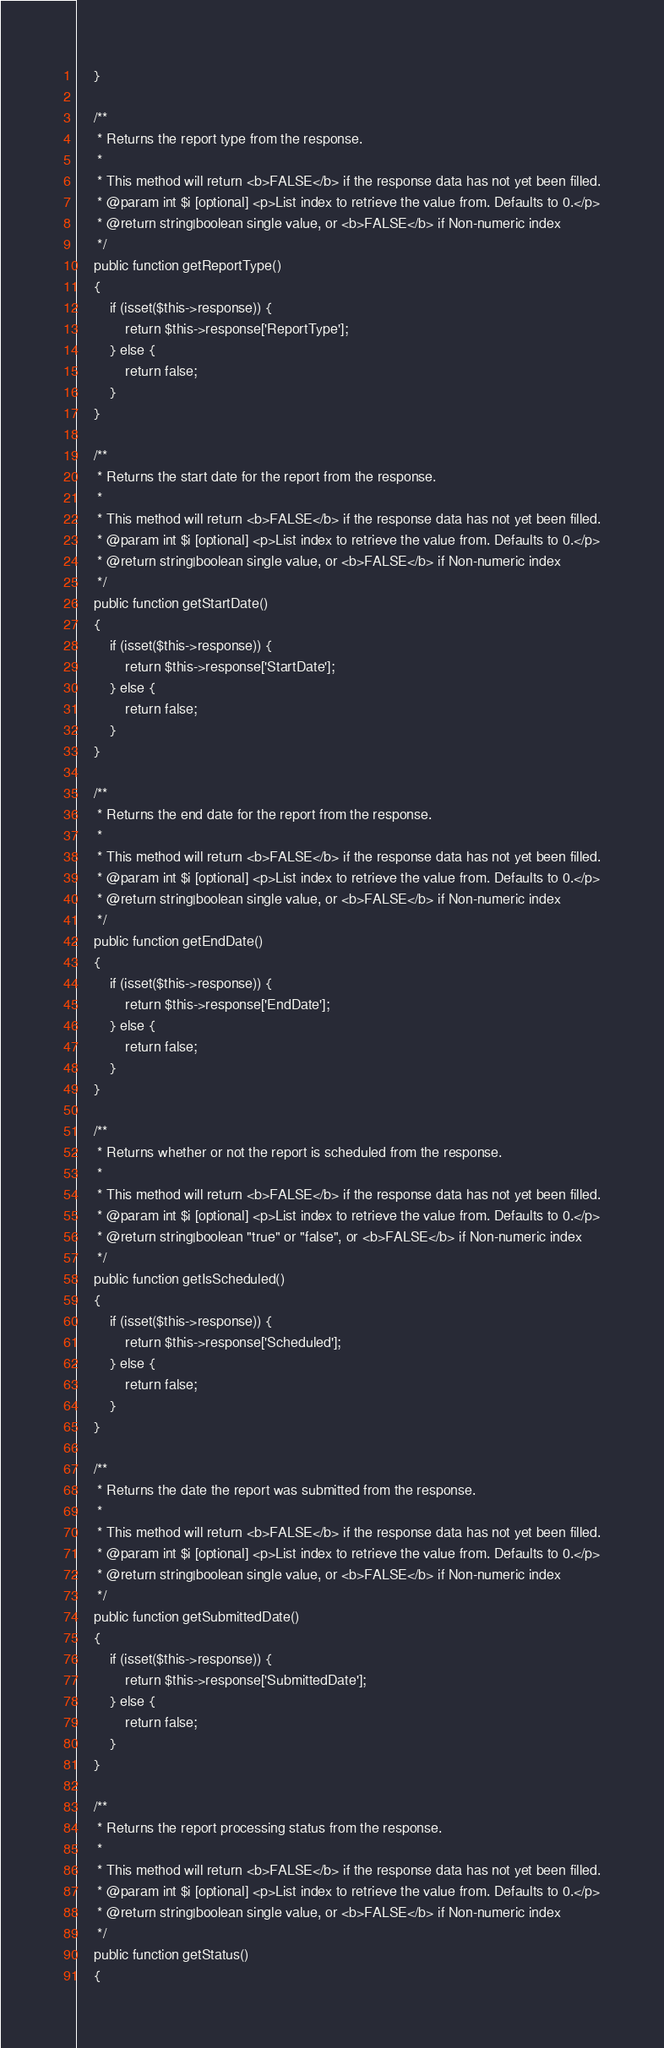Convert code to text. <code><loc_0><loc_0><loc_500><loc_500><_PHP_>    }

    /**
     * Returns the report type from the response.
     *
     * This method will return <b>FALSE</b> if the response data has not yet been filled.
     * @param int $i [optional] <p>List index to retrieve the value from. Defaults to 0.</p>
     * @return string|boolean single value, or <b>FALSE</b> if Non-numeric index
     */
    public function getReportType()
    {
        if (isset($this->response)) {
            return $this->response['ReportType'];
        } else {
            return false;
        }
    }

    /**
     * Returns the start date for the report from the response.
     *
     * This method will return <b>FALSE</b> if the response data has not yet been filled.
     * @param int $i [optional] <p>List index to retrieve the value from. Defaults to 0.</p>
     * @return string|boolean single value, or <b>FALSE</b> if Non-numeric index
     */
    public function getStartDate()
    {
        if (isset($this->response)) {
            return $this->response['StartDate'];
        } else {
            return false;
        }
    }

    /**
     * Returns the end date for the report from the response.
     *
     * This method will return <b>FALSE</b> if the response data has not yet been filled.
     * @param int $i [optional] <p>List index to retrieve the value from. Defaults to 0.</p>
     * @return string|boolean single value, or <b>FALSE</b> if Non-numeric index
     */
    public function getEndDate()
    {
        if (isset($this->response)) {
            return $this->response['EndDate'];
        } else {
            return false;
        }
    }

    /**
     * Returns whether or not the report is scheduled from the response.
     *
     * This method will return <b>FALSE</b> if the response data has not yet been filled.
     * @param int $i [optional] <p>List index to retrieve the value from. Defaults to 0.</p>
     * @return string|boolean "true" or "false", or <b>FALSE</b> if Non-numeric index
     */
    public function getIsScheduled()
    {
        if (isset($this->response)) {
            return $this->response['Scheduled'];
        } else {
            return false;
        }
    }

    /**
     * Returns the date the report was submitted from the response.
     *
     * This method will return <b>FALSE</b> if the response data has not yet been filled.
     * @param int $i [optional] <p>List index to retrieve the value from. Defaults to 0.</p>
     * @return string|boolean single value, or <b>FALSE</b> if Non-numeric index
     */
    public function getSubmittedDate()
    {
        if (isset($this->response)) {
            return $this->response['SubmittedDate'];
        } else {
            return false;
        }
    }

    /**
     * Returns the report processing status from the response.
     *
     * This method will return <b>FALSE</b> if the response data has not yet been filled.
     * @param int $i [optional] <p>List index to retrieve the value from. Defaults to 0.</p>
     * @return string|boolean single value, or <b>FALSE</b> if Non-numeric index
     */
    public function getStatus()
    {</code> 